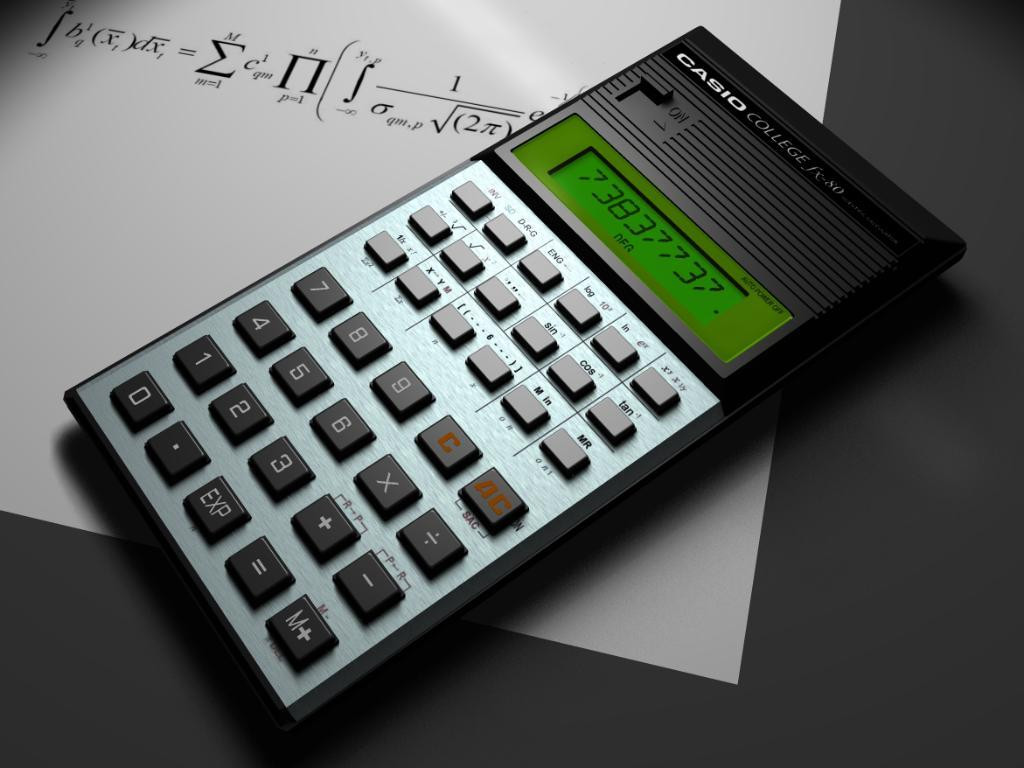What device is present in the image? There is a calculator in the image. What feature does the calculator have? The calculator has a display. What is written on the white paper in the image? There is a formula written on a white paper. What is the color of the table where the white paper is placed? The white paper is on a black table. Can you see a basket full of toads on the calculator in the image? No, there is no basket or toads present in the image. 